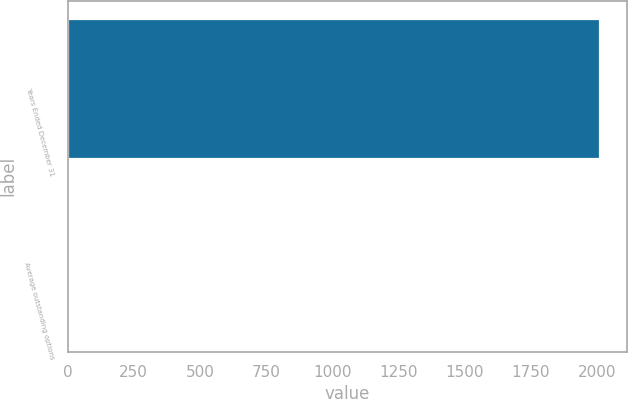Convert chart to OTSL. <chart><loc_0><loc_0><loc_500><loc_500><bar_chart><fcel>Years Ended December 31<fcel>Average outstanding options<nl><fcel>2013<fcel>10.8<nl></chart> 